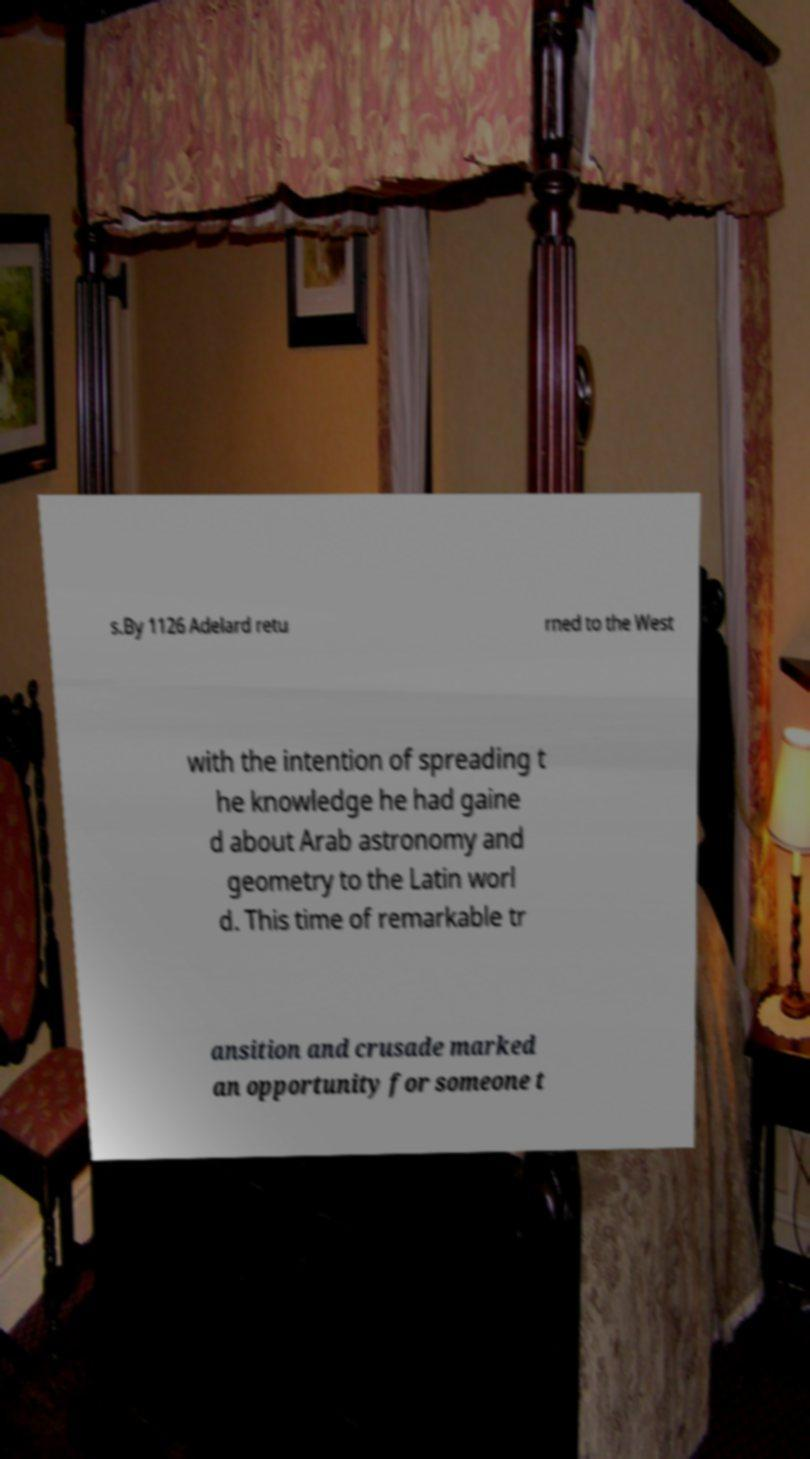Can you read and provide the text displayed in the image?This photo seems to have some interesting text. Can you extract and type it out for me? s.By 1126 Adelard retu rned to the West with the intention of spreading t he knowledge he had gaine d about Arab astronomy and geometry to the Latin worl d. This time of remarkable tr ansition and crusade marked an opportunity for someone t 